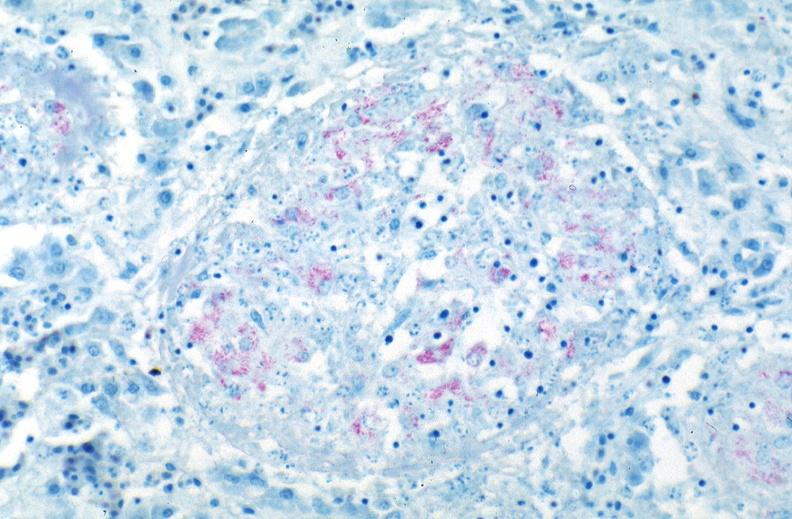what is present?
Answer the question using a single word or phrase. Respiratory 